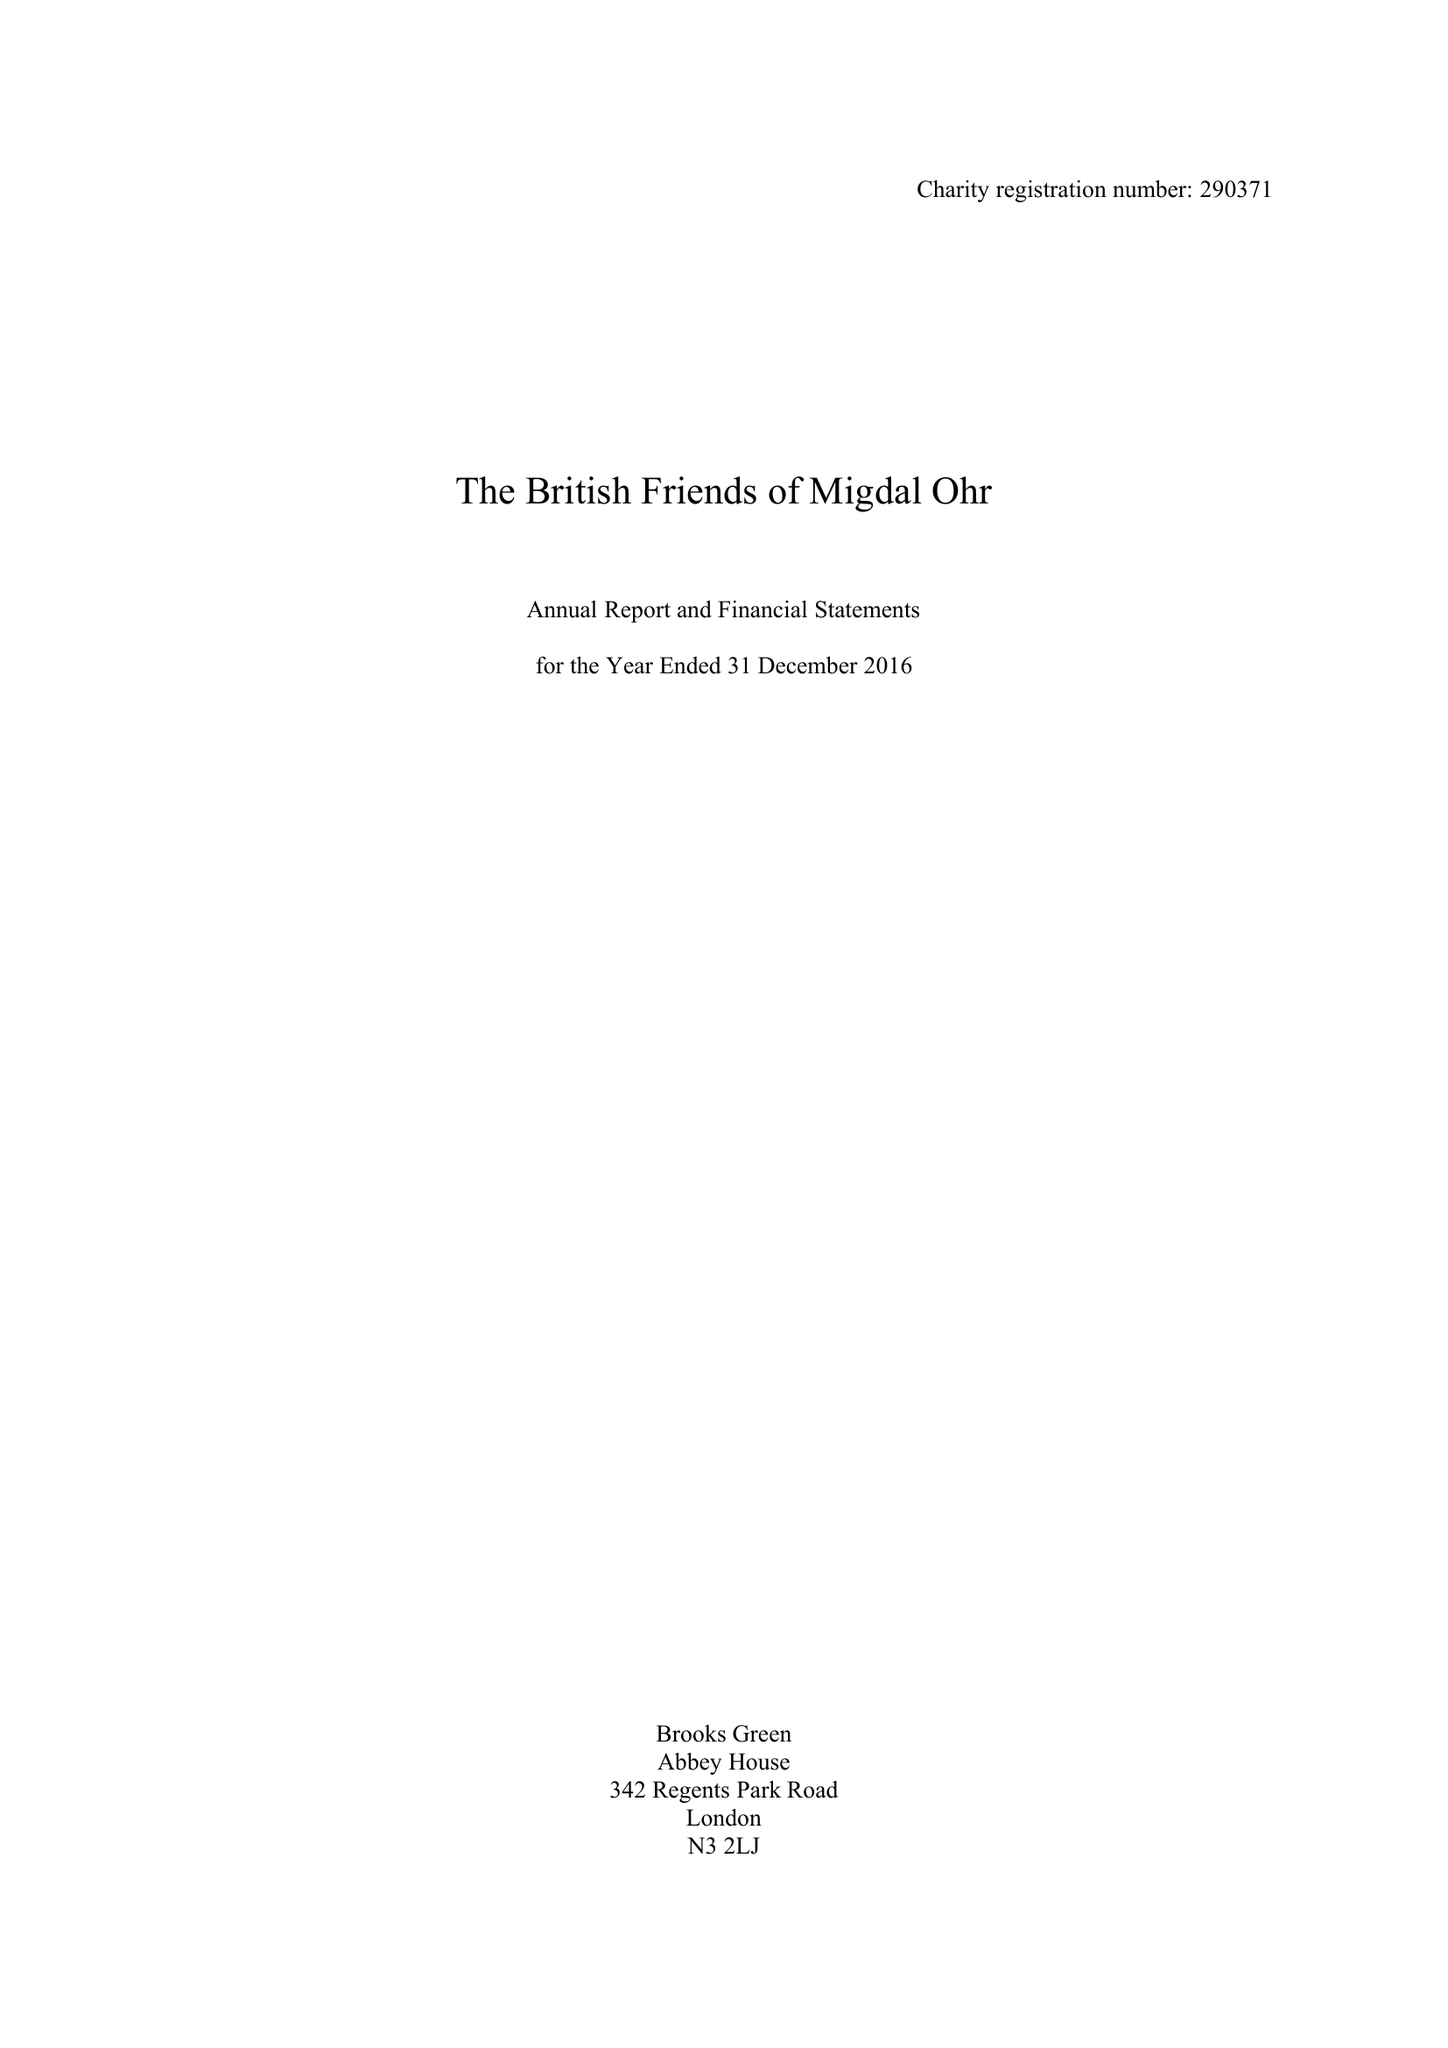What is the value for the report_date?
Answer the question using a single word or phrase. 2016-12-31 